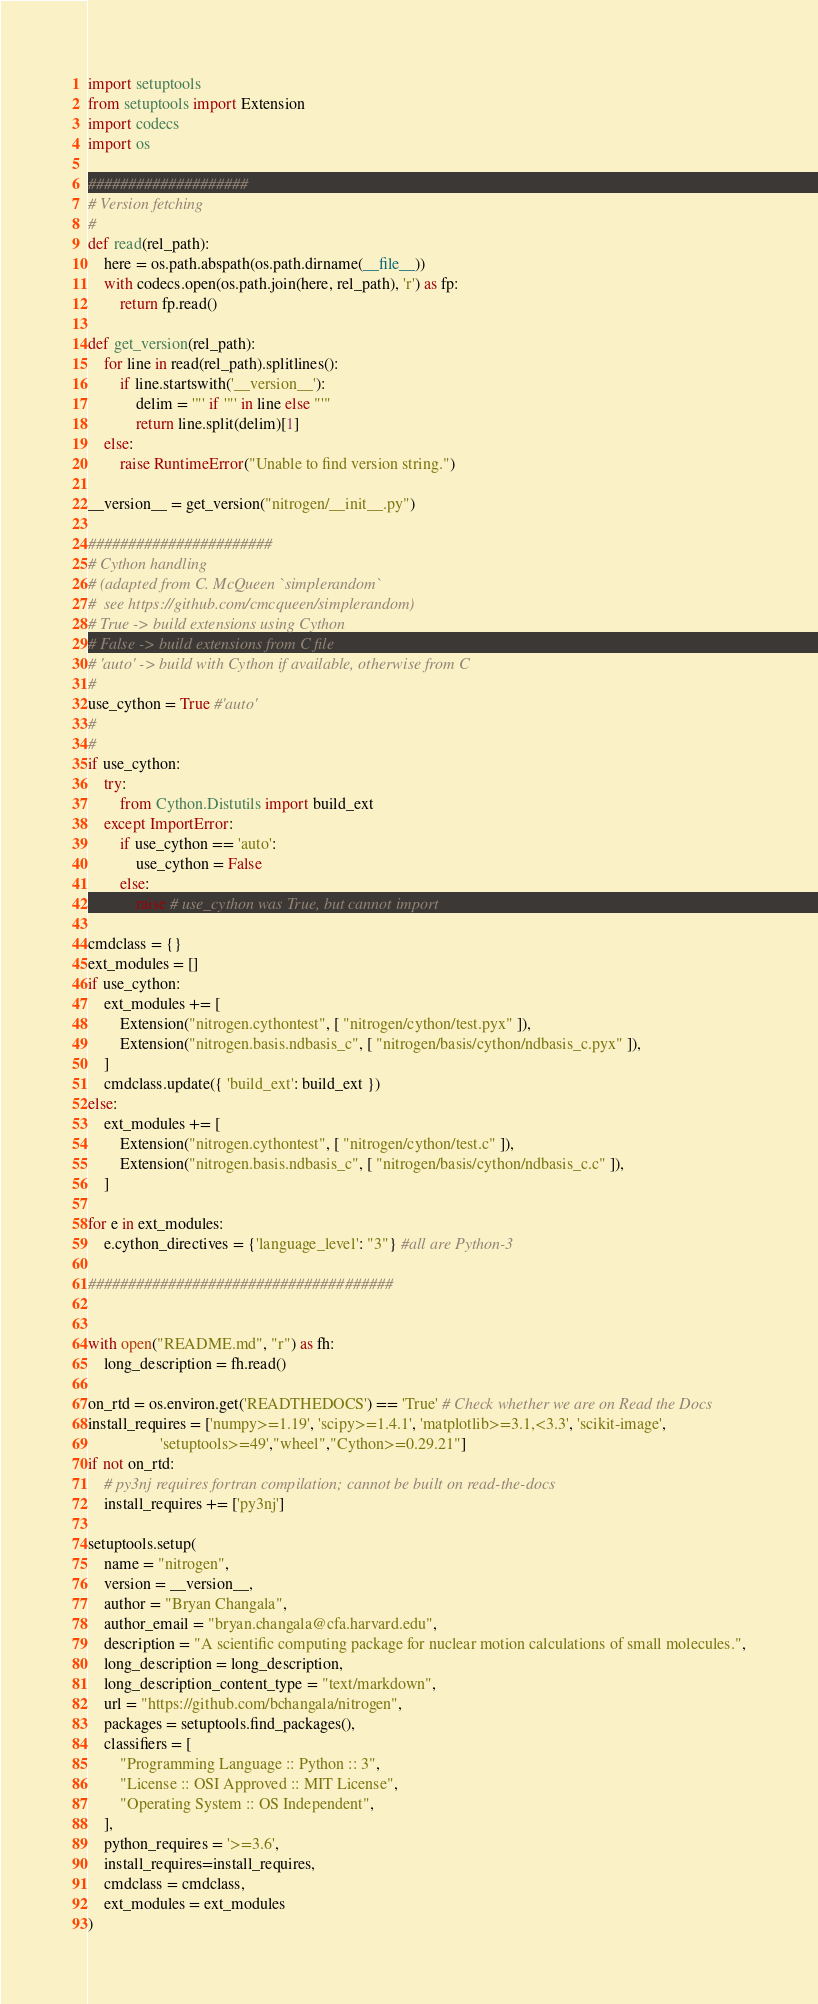Convert code to text. <code><loc_0><loc_0><loc_500><loc_500><_Python_>import setuptools
from setuptools import Extension
import codecs
import os

####################
# Version fetching
#
def read(rel_path):
    here = os.path.abspath(os.path.dirname(__file__))
    with codecs.open(os.path.join(here, rel_path), 'r') as fp:
        return fp.read()

def get_version(rel_path):
    for line in read(rel_path).splitlines():
        if line.startswith('__version__'):
            delim = '"' if '"' in line else "'"
            return line.split(delim)[1]
    else:
        raise RuntimeError("Unable to find version string.")
        
__version__ = get_version("nitrogen/__init__.py")
        
#######################
# Cython handling
# (adapted from C. McQueen `simplerandom`
#  see https://github.com/cmcqueen/simplerandom)
# True -> build extensions using Cython
# False -> build extensions from C file
# 'auto' -> build with Cython if available, otherwise from C
#
use_cython = True #'auto'
#
#
if use_cython:
    try:
        from Cython.Distutils import build_ext
    except ImportError:
        if use_cython == 'auto':
            use_cython = False 
        else:
            raise # use_cython was True, but cannot import 
            
cmdclass = {}
ext_modules = []
if use_cython:
    ext_modules += [
        Extension("nitrogen.cythontest", [ "nitrogen/cython/test.pyx" ]),
        Extension("nitrogen.basis.ndbasis_c", [ "nitrogen/basis/cython/ndbasis_c.pyx" ]),
    ]
    cmdclass.update({ 'build_ext': build_ext })
else:
    ext_modules += [
        Extension("nitrogen.cythontest", [ "nitrogen/cython/test.c" ]),
        Extension("nitrogen.basis.ndbasis_c", [ "nitrogen/basis/cython/ndbasis_c.c" ]),
    ]
    
for e in ext_modules:
    e.cython_directives = {'language_level': "3"} #all are Python-3
    
######################################


with open("README.md", "r") as fh:
	long_description = fh.read()
    
on_rtd = os.environ.get('READTHEDOCS') == 'True' # Check whether we are on Read the Docs
install_requires = ['numpy>=1.19', 'scipy>=1.4.1', 'matplotlib>=3.1,<3.3', 'scikit-image',
                  'setuptools>=49',"wheel","Cython>=0.29.21"]
if not on_rtd:
    # py3nj requires fortran compilation; cannot be built on read-the-docs
    install_requires += ['py3nj']
	
setuptools.setup(
	name = "nitrogen",
	version = __version__,
	author = "Bryan Changala",
	author_email = "bryan.changala@cfa.harvard.edu",
	description = "A scientific computing package for nuclear motion calculations of small molecules.",
	long_description = long_description,
	long_description_content_type = "text/markdown",
	url = "https://github.com/bchangala/nitrogen",
	packages = setuptools.find_packages(),
	classifiers = [
		"Programming Language :: Python :: 3",
		"License :: OSI Approved :: MIT License",
		"Operating System :: OS Independent",
	],
	python_requires = '>=3.6', 
    install_requires=install_requires,
    cmdclass = cmdclass,
    ext_modules = ext_modules
)</code> 